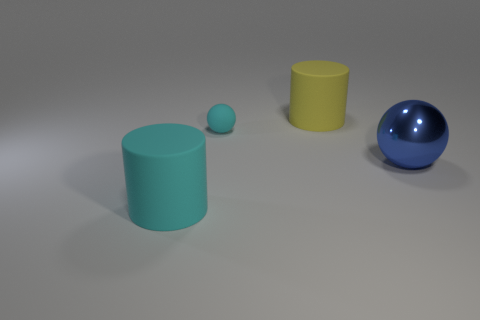Add 3 rubber spheres. How many objects exist? 7 Subtract all matte balls. Subtract all large matte things. How many objects are left? 1 Add 3 cyan things. How many cyan things are left? 5 Add 4 large balls. How many large balls exist? 5 Subtract 0 green cylinders. How many objects are left? 4 